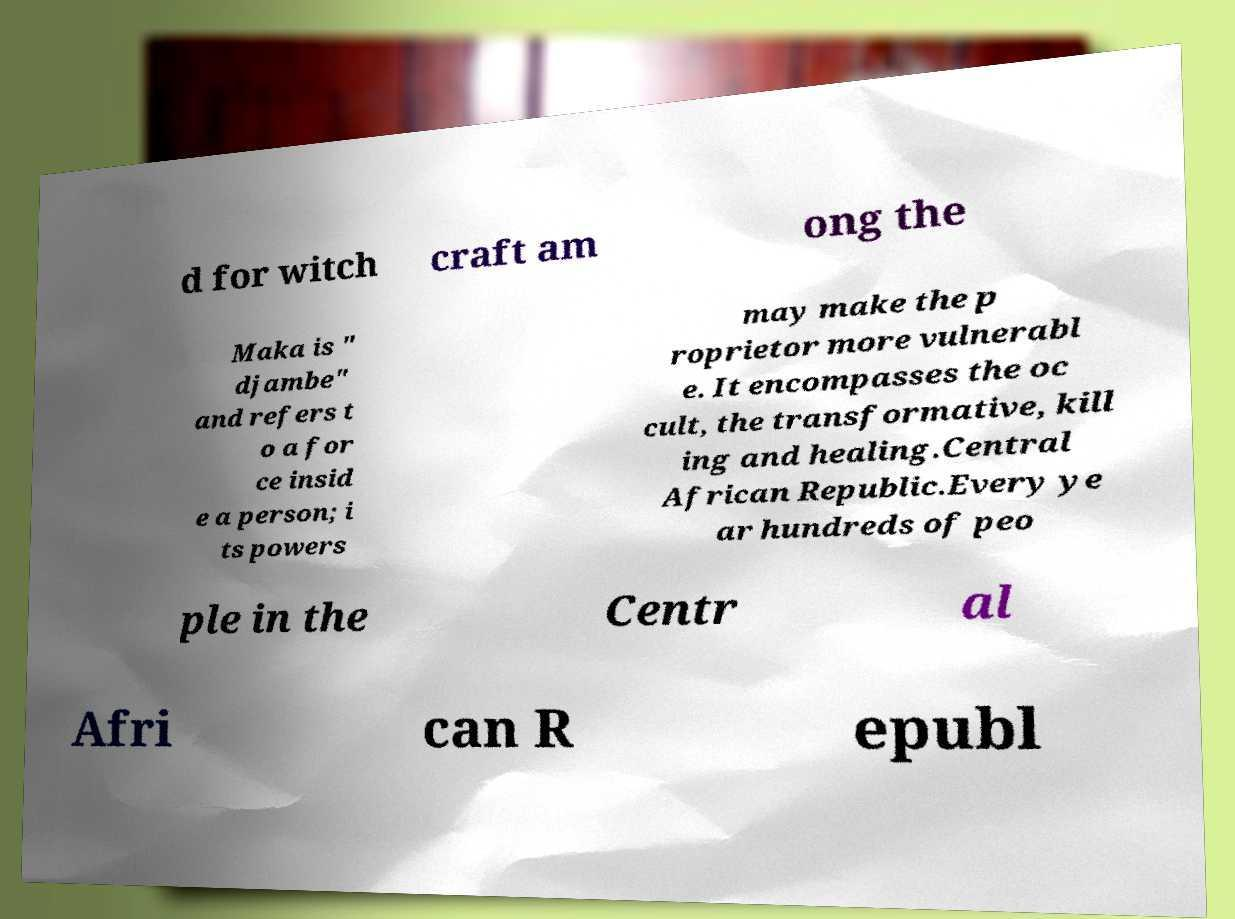Could you assist in decoding the text presented in this image and type it out clearly? d for witch craft am ong the Maka is " djambe" and refers t o a for ce insid e a person; i ts powers may make the p roprietor more vulnerabl e. It encompasses the oc cult, the transformative, kill ing and healing.Central African Republic.Every ye ar hundreds of peo ple in the Centr al Afri can R epubl 